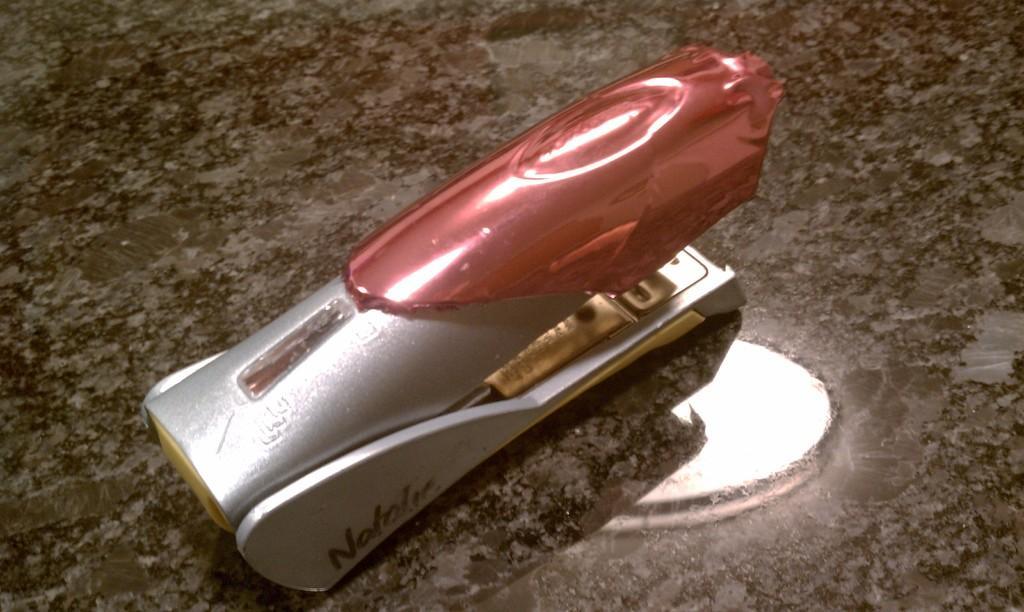In one or two sentences, can you explain what this image depicts? In this picture we can see a stapler in the front, at the bottom there is a flat surface, we can see reflection of a light on it. 